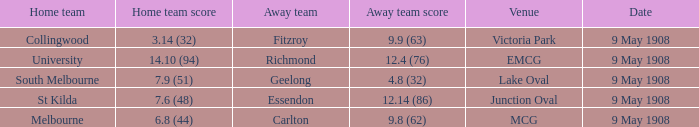Name the home team for carlton away team Melbourne. Could you parse the entire table as a dict? {'header': ['Home team', 'Home team score', 'Away team', 'Away team score', 'Venue', 'Date'], 'rows': [['Collingwood', '3.14 (32)', 'Fitzroy', '9.9 (63)', 'Victoria Park', '9 May 1908'], ['University', '14.10 (94)', 'Richmond', '12.4 (76)', 'EMCG', '9 May 1908'], ['South Melbourne', '7.9 (51)', 'Geelong', '4.8 (32)', 'Lake Oval', '9 May 1908'], ['St Kilda', '7.6 (48)', 'Essendon', '12.14 (86)', 'Junction Oval', '9 May 1908'], ['Melbourne', '6.8 (44)', 'Carlton', '9.8 (62)', 'MCG', '9 May 1908']]} 